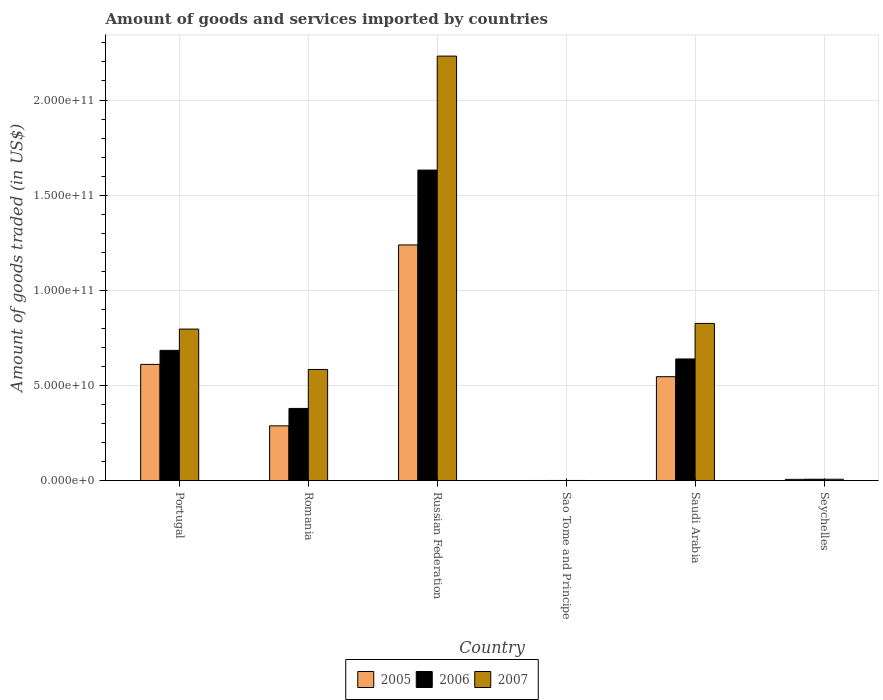How many different coloured bars are there?
Your answer should be compact. 3. How many bars are there on the 4th tick from the right?
Provide a succinct answer. 3. What is the label of the 5th group of bars from the left?
Keep it short and to the point. Saudi Arabia. In how many cases, is the number of bars for a given country not equal to the number of legend labels?
Keep it short and to the point. 0. What is the total amount of goods and services imported in 2005 in Portugal?
Give a very brief answer. 6.11e+1. Across all countries, what is the maximum total amount of goods and services imported in 2007?
Your response must be concise. 2.23e+11. Across all countries, what is the minimum total amount of goods and services imported in 2006?
Offer a terse response. 5.92e+07. In which country was the total amount of goods and services imported in 2005 maximum?
Keep it short and to the point. Russian Federation. In which country was the total amount of goods and services imported in 2007 minimum?
Offer a terse response. Sao Tome and Principe. What is the total total amount of goods and services imported in 2005 in the graph?
Your answer should be compact. 2.69e+11. What is the difference between the total amount of goods and services imported in 2007 in Sao Tome and Principe and that in Seychelles?
Offer a very short reply. -6.37e+08. What is the difference between the total amount of goods and services imported in 2005 in Seychelles and the total amount of goods and services imported in 2006 in Russian Federation?
Provide a short and direct response. -1.63e+11. What is the average total amount of goods and services imported in 2005 per country?
Make the answer very short. 4.48e+1. What is the difference between the total amount of goods and services imported of/in 2005 and total amount of goods and services imported of/in 2006 in Romania?
Provide a short and direct response. -9.16e+09. What is the ratio of the total amount of goods and services imported in 2005 in Sao Tome and Principe to that in Seychelles?
Keep it short and to the point. 0.06. What is the difference between the highest and the second highest total amount of goods and services imported in 2007?
Provide a succinct answer. 1.40e+11. What is the difference between the highest and the lowest total amount of goods and services imported in 2005?
Offer a very short reply. 1.24e+11. Is the sum of the total amount of goods and services imported in 2007 in Sao Tome and Principe and Saudi Arabia greater than the maximum total amount of goods and services imported in 2006 across all countries?
Your answer should be compact. No. What does the 1st bar from the left in Saudi Arabia represents?
Give a very brief answer. 2005. How many legend labels are there?
Provide a short and direct response. 3. How are the legend labels stacked?
Your answer should be compact. Horizontal. What is the title of the graph?
Provide a short and direct response. Amount of goods and services imported by countries. What is the label or title of the X-axis?
Your answer should be compact. Country. What is the label or title of the Y-axis?
Offer a terse response. Amount of goods traded (in US$). What is the Amount of goods traded (in US$) in 2005 in Portugal?
Make the answer very short. 6.11e+1. What is the Amount of goods traded (in US$) in 2006 in Portugal?
Keep it short and to the point. 6.84e+1. What is the Amount of goods traded (in US$) in 2007 in Portugal?
Keep it short and to the point. 7.96e+1. What is the Amount of goods traded (in US$) in 2005 in Romania?
Offer a terse response. 2.88e+1. What is the Amount of goods traded (in US$) of 2006 in Romania?
Offer a very short reply. 3.79e+1. What is the Amount of goods traded (in US$) of 2007 in Romania?
Your answer should be very brief. 5.84e+1. What is the Amount of goods traded (in US$) of 2005 in Russian Federation?
Provide a short and direct response. 1.24e+11. What is the Amount of goods traded (in US$) in 2006 in Russian Federation?
Ensure brevity in your answer.  1.63e+11. What is the Amount of goods traded (in US$) of 2007 in Russian Federation?
Keep it short and to the point. 2.23e+11. What is the Amount of goods traded (in US$) in 2005 in Sao Tome and Principe?
Keep it short and to the point. 4.16e+07. What is the Amount of goods traded (in US$) of 2006 in Sao Tome and Principe?
Your answer should be very brief. 5.92e+07. What is the Amount of goods traded (in US$) of 2007 in Sao Tome and Principe?
Keep it short and to the point. 6.49e+07. What is the Amount of goods traded (in US$) in 2005 in Saudi Arabia?
Keep it short and to the point. 5.46e+1. What is the Amount of goods traded (in US$) in 2006 in Saudi Arabia?
Offer a very short reply. 6.39e+1. What is the Amount of goods traded (in US$) in 2007 in Saudi Arabia?
Your answer should be very brief. 8.26e+1. What is the Amount of goods traded (in US$) in 2005 in Seychelles?
Offer a terse response. 6.45e+08. What is the Amount of goods traded (in US$) in 2006 in Seychelles?
Give a very brief answer. 7.02e+08. What is the Amount of goods traded (in US$) of 2007 in Seychelles?
Give a very brief answer. 7.02e+08. Across all countries, what is the maximum Amount of goods traded (in US$) in 2005?
Keep it short and to the point. 1.24e+11. Across all countries, what is the maximum Amount of goods traded (in US$) of 2006?
Provide a succinct answer. 1.63e+11. Across all countries, what is the maximum Amount of goods traded (in US$) in 2007?
Ensure brevity in your answer.  2.23e+11. Across all countries, what is the minimum Amount of goods traded (in US$) in 2005?
Keep it short and to the point. 4.16e+07. Across all countries, what is the minimum Amount of goods traded (in US$) in 2006?
Your answer should be very brief. 5.92e+07. Across all countries, what is the minimum Amount of goods traded (in US$) of 2007?
Your answer should be compact. 6.49e+07. What is the total Amount of goods traded (in US$) of 2005 in the graph?
Offer a very short reply. 2.69e+11. What is the total Amount of goods traded (in US$) in 2006 in the graph?
Offer a terse response. 3.34e+11. What is the total Amount of goods traded (in US$) in 2007 in the graph?
Your answer should be compact. 4.44e+11. What is the difference between the Amount of goods traded (in US$) of 2005 in Portugal and that in Romania?
Your answer should be very brief. 3.23e+1. What is the difference between the Amount of goods traded (in US$) in 2006 in Portugal and that in Romania?
Your answer should be very brief. 3.05e+1. What is the difference between the Amount of goods traded (in US$) in 2007 in Portugal and that in Romania?
Your answer should be compact. 2.12e+1. What is the difference between the Amount of goods traded (in US$) of 2005 in Portugal and that in Russian Federation?
Ensure brevity in your answer.  -6.28e+1. What is the difference between the Amount of goods traded (in US$) of 2006 in Portugal and that in Russian Federation?
Your answer should be compact. -9.48e+1. What is the difference between the Amount of goods traded (in US$) of 2007 in Portugal and that in Russian Federation?
Your response must be concise. -1.43e+11. What is the difference between the Amount of goods traded (in US$) in 2005 in Portugal and that in Sao Tome and Principe?
Make the answer very short. 6.10e+1. What is the difference between the Amount of goods traded (in US$) of 2006 in Portugal and that in Sao Tome and Principe?
Make the answer very short. 6.84e+1. What is the difference between the Amount of goods traded (in US$) in 2007 in Portugal and that in Sao Tome and Principe?
Your answer should be compact. 7.96e+1. What is the difference between the Amount of goods traded (in US$) in 2005 in Portugal and that in Saudi Arabia?
Offer a very short reply. 6.47e+09. What is the difference between the Amount of goods traded (in US$) in 2006 in Portugal and that in Saudi Arabia?
Your answer should be compact. 4.51e+09. What is the difference between the Amount of goods traded (in US$) of 2007 in Portugal and that in Saudi Arabia?
Provide a succinct answer. -2.98e+09. What is the difference between the Amount of goods traded (in US$) in 2005 in Portugal and that in Seychelles?
Offer a terse response. 6.04e+1. What is the difference between the Amount of goods traded (in US$) in 2006 in Portugal and that in Seychelles?
Your answer should be very brief. 6.77e+1. What is the difference between the Amount of goods traded (in US$) of 2007 in Portugal and that in Seychelles?
Make the answer very short. 7.89e+1. What is the difference between the Amount of goods traded (in US$) of 2005 in Romania and that in Russian Federation?
Provide a short and direct response. -9.51e+1. What is the difference between the Amount of goods traded (in US$) of 2006 in Romania and that in Russian Federation?
Make the answer very short. -1.25e+11. What is the difference between the Amount of goods traded (in US$) of 2007 in Romania and that in Russian Federation?
Your answer should be compact. -1.65e+11. What is the difference between the Amount of goods traded (in US$) of 2005 in Romania and that in Sao Tome and Principe?
Give a very brief answer. 2.87e+1. What is the difference between the Amount of goods traded (in US$) in 2006 in Romania and that in Sao Tome and Principe?
Keep it short and to the point. 3.79e+1. What is the difference between the Amount of goods traded (in US$) in 2007 in Romania and that in Sao Tome and Principe?
Provide a succinct answer. 5.83e+1. What is the difference between the Amount of goods traded (in US$) in 2005 in Romania and that in Saudi Arabia?
Provide a short and direct response. -2.58e+1. What is the difference between the Amount of goods traded (in US$) in 2006 in Romania and that in Saudi Arabia?
Provide a short and direct response. -2.60e+1. What is the difference between the Amount of goods traded (in US$) in 2007 in Romania and that in Saudi Arabia?
Provide a short and direct response. -2.42e+1. What is the difference between the Amount of goods traded (in US$) of 2005 in Romania and that in Seychelles?
Provide a succinct answer. 2.81e+1. What is the difference between the Amount of goods traded (in US$) of 2006 in Romania and that in Seychelles?
Provide a succinct answer. 3.72e+1. What is the difference between the Amount of goods traded (in US$) of 2007 in Romania and that in Seychelles?
Offer a terse response. 5.77e+1. What is the difference between the Amount of goods traded (in US$) in 2005 in Russian Federation and that in Sao Tome and Principe?
Ensure brevity in your answer.  1.24e+11. What is the difference between the Amount of goods traded (in US$) of 2006 in Russian Federation and that in Sao Tome and Principe?
Provide a short and direct response. 1.63e+11. What is the difference between the Amount of goods traded (in US$) of 2007 in Russian Federation and that in Sao Tome and Principe?
Offer a terse response. 2.23e+11. What is the difference between the Amount of goods traded (in US$) of 2005 in Russian Federation and that in Saudi Arabia?
Your answer should be compact. 6.92e+1. What is the difference between the Amount of goods traded (in US$) of 2006 in Russian Federation and that in Saudi Arabia?
Your response must be concise. 9.93e+1. What is the difference between the Amount of goods traded (in US$) in 2007 in Russian Federation and that in Saudi Arabia?
Make the answer very short. 1.40e+11. What is the difference between the Amount of goods traded (in US$) in 2005 in Russian Federation and that in Seychelles?
Offer a terse response. 1.23e+11. What is the difference between the Amount of goods traded (in US$) of 2006 in Russian Federation and that in Seychelles?
Ensure brevity in your answer.  1.62e+11. What is the difference between the Amount of goods traded (in US$) of 2007 in Russian Federation and that in Seychelles?
Keep it short and to the point. 2.22e+11. What is the difference between the Amount of goods traded (in US$) in 2005 in Sao Tome and Principe and that in Saudi Arabia?
Keep it short and to the point. -5.46e+1. What is the difference between the Amount of goods traded (in US$) in 2006 in Sao Tome and Principe and that in Saudi Arabia?
Provide a succinct answer. -6.39e+1. What is the difference between the Amount of goods traded (in US$) in 2007 in Sao Tome and Principe and that in Saudi Arabia?
Make the answer very short. -8.25e+1. What is the difference between the Amount of goods traded (in US$) in 2005 in Sao Tome and Principe and that in Seychelles?
Your response must be concise. -6.03e+08. What is the difference between the Amount of goods traded (in US$) in 2006 in Sao Tome and Principe and that in Seychelles?
Keep it short and to the point. -6.43e+08. What is the difference between the Amount of goods traded (in US$) in 2007 in Sao Tome and Principe and that in Seychelles?
Keep it short and to the point. -6.37e+08. What is the difference between the Amount of goods traded (in US$) in 2005 in Saudi Arabia and that in Seychelles?
Offer a very short reply. 5.40e+1. What is the difference between the Amount of goods traded (in US$) in 2006 in Saudi Arabia and that in Seychelles?
Your response must be concise. 6.32e+1. What is the difference between the Amount of goods traded (in US$) of 2007 in Saudi Arabia and that in Seychelles?
Ensure brevity in your answer.  8.19e+1. What is the difference between the Amount of goods traded (in US$) of 2005 in Portugal and the Amount of goods traded (in US$) of 2006 in Romania?
Provide a succinct answer. 2.31e+1. What is the difference between the Amount of goods traded (in US$) of 2005 in Portugal and the Amount of goods traded (in US$) of 2007 in Romania?
Your answer should be compact. 2.66e+09. What is the difference between the Amount of goods traded (in US$) in 2006 in Portugal and the Amount of goods traded (in US$) in 2007 in Romania?
Offer a very short reply. 1.00e+1. What is the difference between the Amount of goods traded (in US$) in 2005 in Portugal and the Amount of goods traded (in US$) in 2006 in Russian Federation?
Give a very brief answer. -1.02e+11. What is the difference between the Amount of goods traded (in US$) of 2005 in Portugal and the Amount of goods traded (in US$) of 2007 in Russian Federation?
Your response must be concise. -1.62e+11. What is the difference between the Amount of goods traded (in US$) in 2006 in Portugal and the Amount of goods traded (in US$) in 2007 in Russian Federation?
Your answer should be very brief. -1.55e+11. What is the difference between the Amount of goods traded (in US$) in 2005 in Portugal and the Amount of goods traded (in US$) in 2006 in Sao Tome and Principe?
Your response must be concise. 6.10e+1. What is the difference between the Amount of goods traded (in US$) in 2005 in Portugal and the Amount of goods traded (in US$) in 2007 in Sao Tome and Principe?
Your answer should be very brief. 6.10e+1. What is the difference between the Amount of goods traded (in US$) of 2006 in Portugal and the Amount of goods traded (in US$) of 2007 in Sao Tome and Principe?
Your answer should be very brief. 6.84e+1. What is the difference between the Amount of goods traded (in US$) in 2005 in Portugal and the Amount of goods traded (in US$) in 2006 in Saudi Arabia?
Your response must be concise. -2.85e+09. What is the difference between the Amount of goods traded (in US$) of 2005 in Portugal and the Amount of goods traded (in US$) of 2007 in Saudi Arabia?
Your answer should be very brief. -2.15e+1. What is the difference between the Amount of goods traded (in US$) in 2006 in Portugal and the Amount of goods traded (in US$) in 2007 in Saudi Arabia?
Provide a succinct answer. -1.42e+1. What is the difference between the Amount of goods traded (in US$) in 2005 in Portugal and the Amount of goods traded (in US$) in 2006 in Seychelles?
Keep it short and to the point. 6.04e+1. What is the difference between the Amount of goods traded (in US$) in 2005 in Portugal and the Amount of goods traded (in US$) in 2007 in Seychelles?
Give a very brief answer. 6.04e+1. What is the difference between the Amount of goods traded (in US$) of 2006 in Portugal and the Amount of goods traded (in US$) of 2007 in Seychelles?
Your answer should be very brief. 6.77e+1. What is the difference between the Amount of goods traded (in US$) of 2005 in Romania and the Amount of goods traded (in US$) of 2006 in Russian Federation?
Offer a terse response. -1.34e+11. What is the difference between the Amount of goods traded (in US$) in 2005 in Romania and the Amount of goods traded (in US$) in 2007 in Russian Federation?
Your answer should be compact. -1.94e+11. What is the difference between the Amount of goods traded (in US$) of 2006 in Romania and the Amount of goods traded (in US$) of 2007 in Russian Federation?
Your answer should be very brief. -1.85e+11. What is the difference between the Amount of goods traded (in US$) of 2005 in Romania and the Amount of goods traded (in US$) of 2006 in Sao Tome and Principe?
Offer a terse response. 2.87e+1. What is the difference between the Amount of goods traded (in US$) in 2005 in Romania and the Amount of goods traded (in US$) in 2007 in Sao Tome and Principe?
Offer a terse response. 2.87e+1. What is the difference between the Amount of goods traded (in US$) of 2006 in Romania and the Amount of goods traded (in US$) of 2007 in Sao Tome and Principe?
Your answer should be compact. 3.79e+1. What is the difference between the Amount of goods traded (in US$) in 2005 in Romania and the Amount of goods traded (in US$) in 2006 in Saudi Arabia?
Your answer should be very brief. -3.52e+1. What is the difference between the Amount of goods traded (in US$) of 2005 in Romania and the Amount of goods traded (in US$) of 2007 in Saudi Arabia?
Provide a short and direct response. -5.38e+1. What is the difference between the Amount of goods traded (in US$) in 2006 in Romania and the Amount of goods traded (in US$) in 2007 in Saudi Arabia?
Your response must be concise. -4.47e+1. What is the difference between the Amount of goods traded (in US$) of 2005 in Romania and the Amount of goods traded (in US$) of 2006 in Seychelles?
Give a very brief answer. 2.81e+1. What is the difference between the Amount of goods traded (in US$) of 2005 in Romania and the Amount of goods traded (in US$) of 2007 in Seychelles?
Your answer should be very brief. 2.81e+1. What is the difference between the Amount of goods traded (in US$) of 2006 in Romania and the Amount of goods traded (in US$) of 2007 in Seychelles?
Provide a short and direct response. 3.72e+1. What is the difference between the Amount of goods traded (in US$) in 2005 in Russian Federation and the Amount of goods traded (in US$) in 2006 in Sao Tome and Principe?
Your response must be concise. 1.24e+11. What is the difference between the Amount of goods traded (in US$) of 2005 in Russian Federation and the Amount of goods traded (in US$) of 2007 in Sao Tome and Principe?
Ensure brevity in your answer.  1.24e+11. What is the difference between the Amount of goods traded (in US$) of 2006 in Russian Federation and the Amount of goods traded (in US$) of 2007 in Sao Tome and Principe?
Give a very brief answer. 1.63e+11. What is the difference between the Amount of goods traded (in US$) of 2005 in Russian Federation and the Amount of goods traded (in US$) of 2006 in Saudi Arabia?
Your answer should be very brief. 5.99e+1. What is the difference between the Amount of goods traded (in US$) in 2005 in Russian Federation and the Amount of goods traded (in US$) in 2007 in Saudi Arabia?
Keep it short and to the point. 4.12e+1. What is the difference between the Amount of goods traded (in US$) in 2006 in Russian Federation and the Amount of goods traded (in US$) in 2007 in Saudi Arabia?
Provide a short and direct response. 8.06e+1. What is the difference between the Amount of goods traded (in US$) of 2005 in Russian Federation and the Amount of goods traded (in US$) of 2006 in Seychelles?
Make the answer very short. 1.23e+11. What is the difference between the Amount of goods traded (in US$) in 2005 in Russian Federation and the Amount of goods traded (in US$) in 2007 in Seychelles?
Give a very brief answer. 1.23e+11. What is the difference between the Amount of goods traded (in US$) in 2006 in Russian Federation and the Amount of goods traded (in US$) in 2007 in Seychelles?
Give a very brief answer. 1.62e+11. What is the difference between the Amount of goods traded (in US$) in 2005 in Sao Tome and Principe and the Amount of goods traded (in US$) in 2006 in Saudi Arabia?
Your answer should be compact. -6.39e+1. What is the difference between the Amount of goods traded (in US$) in 2005 in Sao Tome and Principe and the Amount of goods traded (in US$) in 2007 in Saudi Arabia?
Your answer should be compact. -8.26e+1. What is the difference between the Amount of goods traded (in US$) in 2006 in Sao Tome and Principe and the Amount of goods traded (in US$) in 2007 in Saudi Arabia?
Ensure brevity in your answer.  -8.25e+1. What is the difference between the Amount of goods traded (in US$) of 2005 in Sao Tome and Principe and the Amount of goods traded (in US$) of 2006 in Seychelles?
Give a very brief answer. -6.60e+08. What is the difference between the Amount of goods traded (in US$) in 2005 in Sao Tome and Principe and the Amount of goods traded (in US$) in 2007 in Seychelles?
Give a very brief answer. -6.60e+08. What is the difference between the Amount of goods traded (in US$) in 2006 in Sao Tome and Principe and the Amount of goods traded (in US$) in 2007 in Seychelles?
Provide a short and direct response. -6.43e+08. What is the difference between the Amount of goods traded (in US$) in 2005 in Saudi Arabia and the Amount of goods traded (in US$) in 2006 in Seychelles?
Give a very brief answer. 5.39e+1. What is the difference between the Amount of goods traded (in US$) in 2005 in Saudi Arabia and the Amount of goods traded (in US$) in 2007 in Seychelles?
Your answer should be compact. 5.39e+1. What is the difference between the Amount of goods traded (in US$) of 2006 in Saudi Arabia and the Amount of goods traded (in US$) of 2007 in Seychelles?
Your response must be concise. 6.32e+1. What is the average Amount of goods traded (in US$) in 2005 per country?
Make the answer very short. 4.48e+1. What is the average Amount of goods traded (in US$) of 2006 per country?
Provide a short and direct response. 5.57e+1. What is the average Amount of goods traded (in US$) in 2007 per country?
Offer a very short reply. 7.41e+1. What is the difference between the Amount of goods traded (in US$) of 2005 and Amount of goods traded (in US$) of 2006 in Portugal?
Your answer should be very brief. -7.37e+09. What is the difference between the Amount of goods traded (in US$) in 2005 and Amount of goods traded (in US$) in 2007 in Portugal?
Your answer should be very brief. -1.86e+1. What is the difference between the Amount of goods traded (in US$) of 2006 and Amount of goods traded (in US$) of 2007 in Portugal?
Offer a terse response. -1.12e+1. What is the difference between the Amount of goods traded (in US$) of 2005 and Amount of goods traded (in US$) of 2006 in Romania?
Ensure brevity in your answer.  -9.16e+09. What is the difference between the Amount of goods traded (in US$) of 2005 and Amount of goods traded (in US$) of 2007 in Romania?
Your answer should be very brief. -2.96e+1. What is the difference between the Amount of goods traded (in US$) in 2006 and Amount of goods traded (in US$) in 2007 in Romania?
Provide a succinct answer. -2.05e+1. What is the difference between the Amount of goods traded (in US$) in 2005 and Amount of goods traded (in US$) in 2006 in Russian Federation?
Provide a succinct answer. -3.93e+1. What is the difference between the Amount of goods traded (in US$) in 2005 and Amount of goods traded (in US$) in 2007 in Russian Federation?
Provide a succinct answer. -9.92e+1. What is the difference between the Amount of goods traded (in US$) in 2006 and Amount of goods traded (in US$) in 2007 in Russian Federation?
Provide a succinct answer. -5.99e+1. What is the difference between the Amount of goods traded (in US$) in 2005 and Amount of goods traded (in US$) in 2006 in Sao Tome and Principe?
Make the answer very short. -1.76e+07. What is the difference between the Amount of goods traded (in US$) of 2005 and Amount of goods traded (in US$) of 2007 in Sao Tome and Principe?
Offer a terse response. -2.33e+07. What is the difference between the Amount of goods traded (in US$) of 2006 and Amount of goods traded (in US$) of 2007 in Sao Tome and Principe?
Offer a terse response. -5.63e+06. What is the difference between the Amount of goods traded (in US$) of 2005 and Amount of goods traded (in US$) of 2006 in Saudi Arabia?
Your answer should be very brief. -9.32e+09. What is the difference between the Amount of goods traded (in US$) of 2005 and Amount of goods traded (in US$) of 2007 in Saudi Arabia?
Keep it short and to the point. -2.80e+1. What is the difference between the Amount of goods traded (in US$) of 2006 and Amount of goods traded (in US$) of 2007 in Saudi Arabia?
Your response must be concise. -1.87e+1. What is the difference between the Amount of goods traded (in US$) of 2005 and Amount of goods traded (in US$) of 2006 in Seychelles?
Offer a very short reply. -5.72e+07. What is the difference between the Amount of goods traded (in US$) of 2005 and Amount of goods traded (in US$) of 2007 in Seychelles?
Your response must be concise. -5.73e+07. What is the difference between the Amount of goods traded (in US$) in 2006 and Amount of goods traded (in US$) in 2007 in Seychelles?
Provide a short and direct response. -1.25e+05. What is the ratio of the Amount of goods traded (in US$) of 2005 in Portugal to that in Romania?
Offer a terse response. 2.12. What is the ratio of the Amount of goods traded (in US$) of 2006 in Portugal to that in Romania?
Give a very brief answer. 1.8. What is the ratio of the Amount of goods traded (in US$) in 2007 in Portugal to that in Romania?
Give a very brief answer. 1.36. What is the ratio of the Amount of goods traded (in US$) in 2005 in Portugal to that in Russian Federation?
Offer a very short reply. 0.49. What is the ratio of the Amount of goods traded (in US$) in 2006 in Portugal to that in Russian Federation?
Make the answer very short. 0.42. What is the ratio of the Amount of goods traded (in US$) of 2007 in Portugal to that in Russian Federation?
Give a very brief answer. 0.36. What is the ratio of the Amount of goods traded (in US$) of 2005 in Portugal to that in Sao Tome and Principe?
Offer a terse response. 1467.84. What is the ratio of the Amount of goods traded (in US$) of 2006 in Portugal to that in Sao Tome and Principe?
Your answer should be compact. 1155.1. What is the ratio of the Amount of goods traded (in US$) of 2007 in Portugal to that in Sao Tome and Principe?
Keep it short and to the point. 1227.43. What is the ratio of the Amount of goods traded (in US$) in 2005 in Portugal to that in Saudi Arabia?
Provide a succinct answer. 1.12. What is the ratio of the Amount of goods traded (in US$) of 2006 in Portugal to that in Saudi Arabia?
Your answer should be compact. 1.07. What is the ratio of the Amount of goods traded (in US$) of 2005 in Portugal to that in Seychelles?
Make the answer very short. 94.74. What is the ratio of the Amount of goods traded (in US$) in 2006 in Portugal to that in Seychelles?
Offer a terse response. 97.51. What is the ratio of the Amount of goods traded (in US$) of 2007 in Portugal to that in Seychelles?
Provide a short and direct response. 113.43. What is the ratio of the Amount of goods traded (in US$) of 2005 in Romania to that in Russian Federation?
Give a very brief answer. 0.23. What is the ratio of the Amount of goods traded (in US$) of 2006 in Romania to that in Russian Federation?
Provide a short and direct response. 0.23. What is the ratio of the Amount of goods traded (in US$) of 2007 in Romania to that in Russian Federation?
Your response must be concise. 0.26. What is the ratio of the Amount of goods traded (in US$) in 2005 in Romania to that in Sao Tome and Principe?
Offer a very short reply. 691.27. What is the ratio of the Amount of goods traded (in US$) of 2006 in Romania to that in Sao Tome and Principe?
Give a very brief answer. 640.04. What is the ratio of the Amount of goods traded (in US$) of 2007 in Romania to that in Sao Tome and Principe?
Ensure brevity in your answer.  900.33. What is the ratio of the Amount of goods traded (in US$) in 2005 in Romania to that in Saudi Arabia?
Your answer should be compact. 0.53. What is the ratio of the Amount of goods traded (in US$) of 2006 in Romania to that in Saudi Arabia?
Ensure brevity in your answer.  0.59. What is the ratio of the Amount of goods traded (in US$) of 2007 in Romania to that in Saudi Arabia?
Provide a succinct answer. 0.71. What is the ratio of the Amount of goods traded (in US$) of 2005 in Romania to that in Seychelles?
Make the answer very short. 44.62. What is the ratio of the Amount of goods traded (in US$) in 2006 in Romania to that in Seychelles?
Provide a succinct answer. 54.03. What is the ratio of the Amount of goods traded (in US$) of 2007 in Romania to that in Seychelles?
Offer a very short reply. 83.21. What is the ratio of the Amount of goods traded (in US$) of 2005 in Russian Federation to that in Sao Tome and Principe?
Keep it short and to the point. 2976.87. What is the ratio of the Amount of goods traded (in US$) of 2006 in Russian Federation to that in Sao Tome and Principe?
Keep it short and to the point. 2754.69. What is the ratio of the Amount of goods traded (in US$) in 2007 in Russian Federation to that in Sao Tome and Principe?
Ensure brevity in your answer.  3439.14. What is the ratio of the Amount of goods traded (in US$) in 2005 in Russian Federation to that in Saudi Arabia?
Ensure brevity in your answer.  2.27. What is the ratio of the Amount of goods traded (in US$) in 2006 in Russian Federation to that in Saudi Arabia?
Provide a succinct answer. 2.55. What is the ratio of the Amount of goods traded (in US$) in 2007 in Russian Federation to that in Saudi Arabia?
Your response must be concise. 2.7. What is the ratio of the Amount of goods traded (in US$) of 2005 in Russian Federation to that in Seychelles?
Provide a short and direct response. 192.13. What is the ratio of the Amount of goods traded (in US$) of 2006 in Russian Federation to that in Seychelles?
Provide a short and direct response. 232.54. What is the ratio of the Amount of goods traded (in US$) of 2007 in Russian Federation to that in Seychelles?
Make the answer very short. 317.83. What is the ratio of the Amount of goods traded (in US$) of 2005 in Sao Tome and Principe to that in Saudi Arabia?
Your answer should be very brief. 0. What is the ratio of the Amount of goods traded (in US$) in 2006 in Sao Tome and Principe to that in Saudi Arabia?
Your response must be concise. 0. What is the ratio of the Amount of goods traded (in US$) in 2007 in Sao Tome and Principe to that in Saudi Arabia?
Your response must be concise. 0. What is the ratio of the Amount of goods traded (in US$) in 2005 in Sao Tome and Principe to that in Seychelles?
Provide a short and direct response. 0.06. What is the ratio of the Amount of goods traded (in US$) of 2006 in Sao Tome and Principe to that in Seychelles?
Your response must be concise. 0.08. What is the ratio of the Amount of goods traded (in US$) in 2007 in Sao Tome and Principe to that in Seychelles?
Provide a succinct answer. 0.09. What is the ratio of the Amount of goods traded (in US$) of 2005 in Saudi Arabia to that in Seychelles?
Your response must be concise. 84.7. What is the ratio of the Amount of goods traded (in US$) of 2006 in Saudi Arabia to that in Seychelles?
Give a very brief answer. 91.08. What is the ratio of the Amount of goods traded (in US$) in 2007 in Saudi Arabia to that in Seychelles?
Offer a very short reply. 117.67. What is the difference between the highest and the second highest Amount of goods traded (in US$) in 2005?
Provide a short and direct response. 6.28e+1. What is the difference between the highest and the second highest Amount of goods traded (in US$) of 2006?
Your answer should be very brief. 9.48e+1. What is the difference between the highest and the second highest Amount of goods traded (in US$) of 2007?
Keep it short and to the point. 1.40e+11. What is the difference between the highest and the lowest Amount of goods traded (in US$) in 2005?
Provide a short and direct response. 1.24e+11. What is the difference between the highest and the lowest Amount of goods traded (in US$) in 2006?
Give a very brief answer. 1.63e+11. What is the difference between the highest and the lowest Amount of goods traded (in US$) of 2007?
Provide a short and direct response. 2.23e+11. 